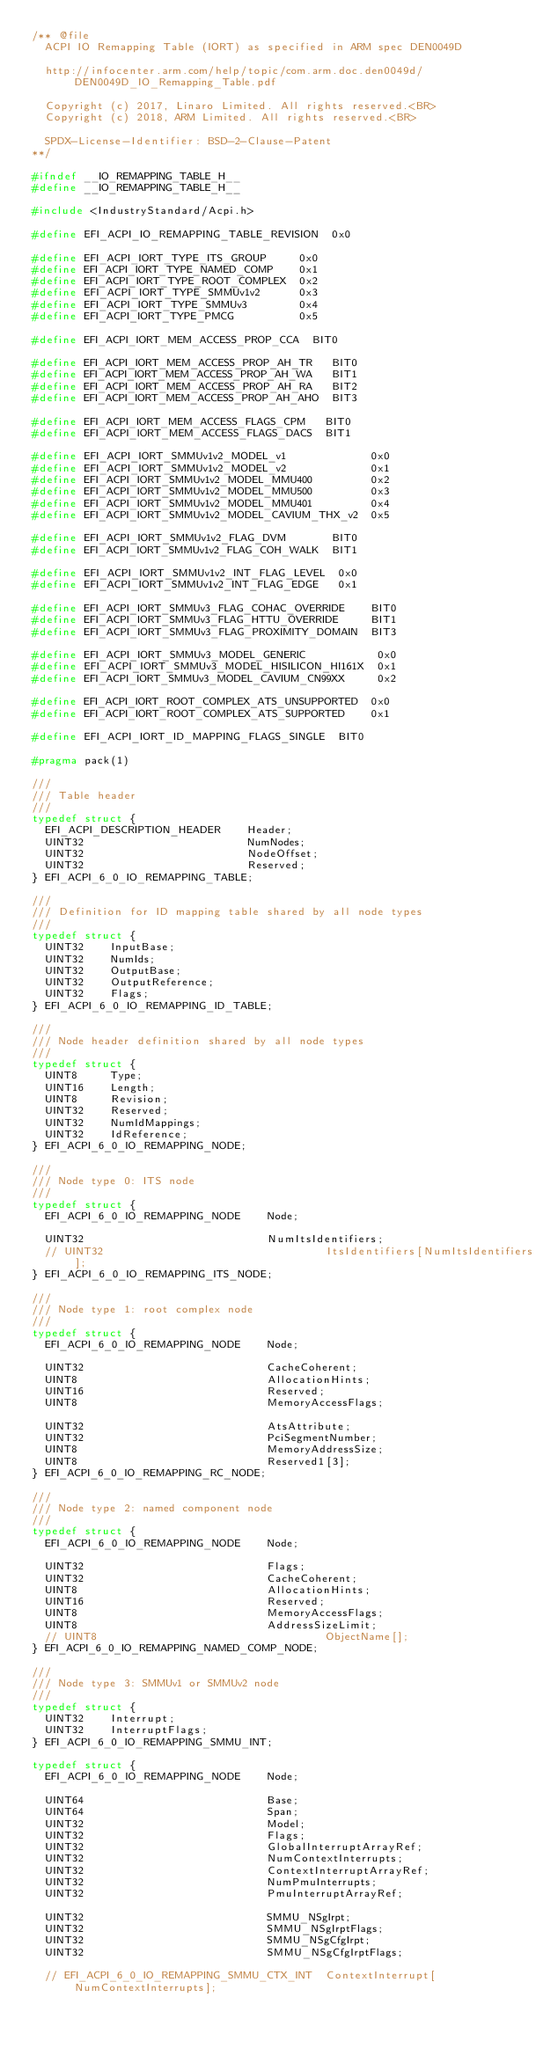<code> <loc_0><loc_0><loc_500><loc_500><_C_>/** @file
  ACPI IO Remapping Table (IORT) as specified in ARM spec DEN0049D

  http://infocenter.arm.com/help/topic/com.arm.doc.den0049d/DEN0049D_IO_Remapping_Table.pdf

  Copyright (c) 2017, Linaro Limited. All rights reserved.<BR>
  Copyright (c) 2018, ARM Limited. All rights reserved.<BR>

  SPDX-License-Identifier: BSD-2-Clause-Patent
**/

#ifndef __IO_REMAPPING_TABLE_H__
#define __IO_REMAPPING_TABLE_H__

#include <IndustryStandard/Acpi.h>

#define EFI_ACPI_IO_REMAPPING_TABLE_REVISION  0x0

#define EFI_ACPI_IORT_TYPE_ITS_GROUP     0x0
#define EFI_ACPI_IORT_TYPE_NAMED_COMP    0x1
#define EFI_ACPI_IORT_TYPE_ROOT_COMPLEX  0x2
#define EFI_ACPI_IORT_TYPE_SMMUv1v2      0x3
#define EFI_ACPI_IORT_TYPE_SMMUv3        0x4
#define EFI_ACPI_IORT_TYPE_PMCG          0x5

#define EFI_ACPI_IORT_MEM_ACCESS_PROP_CCA  BIT0

#define EFI_ACPI_IORT_MEM_ACCESS_PROP_AH_TR   BIT0
#define EFI_ACPI_IORT_MEM_ACCESS_PROP_AH_WA   BIT1
#define EFI_ACPI_IORT_MEM_ACCESS_PROP_AH_RA   BIT2
#define EFI_ACPI_IORT_MEM_ACCESS_PROP_AH_AHO  BIT3

#define EFI_ACPI_IORT_MEM_ACCESS_FLAGS_CPM   BIT0
#define EFI_ACPI_IORT_MEM_ACCESS_FLAGS_DACS  BIT1

#define EFI_ACPI_IORT_SMMUv1v2_MODEL_v1             0x0
#define EFI_ACPI_IORT_SMMUv1v2_MODEL_v2             0x1
#define EFI_ACPI_IORT_SMMUv1v2_MODEL_MMU400         0x2
#define EFI_ACPI_IORT_SMMUv1v2_MODEL_MMU500         0x3
#define EFI_ACPI_IORT_SMMUv1v2_MODEL_MMU401         0x4
#define EFI_ACPI_IORT_SMMUv1v2_MODEL_CAVIUM_THX_v2  0x5

#define EFI_ACPI_IORT_SMMUv1v2_FLAG_DVM       BIT0
#define EFI_ACPI_IORT_SMMUv1v2_FLAG_COH_WALK  BIT1

#define EFI_ACPI_IORT_SMMUv1v2_INT_FLAG_LEVEL  0x0
#define EFI_ACPI_IORT_SMMUv1v2_INT_FLAG_EDGE   0x1

#define EFI_ACPI_IORT_SMMUv3_FLAG_COHAC_OVERRIDE    BIT0
#define EFI_ACPI_IORT_SMMUv3_FLAG_HTTU_OVERRIDE     BIT1
#define EFI_ACPI_IORT_SMMUv3_FLAG_PROXIMITY_DOMAIN  BIT3

#define EFI_ACPI_IORT_SMMUv3_MODEL_GENERIC           0x0
#define EFI_ACPI_IORT_SMMUv3_MODEL_HISILICON_HI161X  0x1
#define EFI_ACPI_IORT_SMMUv3_MODEL_CAVIUM_CN99XX     0x2

#define EFI_ACPI_IORT_ROOT_COMPLEX_ATS_UNSUPPORTED  0x0
#define EFI_ACPI_IORT_ROOT_COMPLEX_ATS_SUPPORTED    0x1

#define EFI_ACPI_IORT_ID_MAPPING_FLAGS_SINGLE  BIT0

#pragma pack(1)

///
/// Table header
///
typedef struct {
  EFI_ACPI_DESCRIPTION_HEADER    Header;
  UINT32                         NumNodes;
  UINT32                         NodeOffset;
  UINT32                         Reserved;
} EFI_ACPI_6_0_IO_REMAPPING_TABLE;

///
/// Definition for ID mapping table shared by all node types
///
typedef struct {
  UINT32    InputBase;
  UINT32    NumIds;
  UINT32    OutputBase;
  UINT32    OutputReference;
  UINT32    Flags;
} EFI_ACPI_6_0_IO_REMAPPING_ID_TABLE;

///
/// Node header definition shared by all node types
///
typedef struct {
  UINT8     Type;
  UINT16    Length;
  UINT8     Revision;
  UINT32    Reserved;
  UINT32    NumIdMappings;
  UINT32    IdReference;
} EFI_ACPI_6_0_IO_REMAPPING_NODE;

///
/// Node type 0: ITS node
///
typedef struct {
  EFI_ACPI_6_0_IO_REMAPPING_NODE    Node;

  UINT32                            NumItsIdentifiers;
  // UINT32                                  ItsIdentifiers[NumItsIdentifiers];
} EFI_ACPI_6_0_IO_REMAPPING_ITS_NODE;

///
/// Node type 1: root complex node
///
typedef struct {
  EFI_ACPI_6_0_IO_REMAPPING_NODE    Node;

  UINT32                            CacheCoherent;
  UINT8                             AllocationHints;
  UINT16                            Reserved;
  UINT8                             MemoryAccessFlags;

  UINT32                            AtsAttribute;
  UINT32                            PciSegmentNumber;
  UINT8                             MemoryAddressSize;
  UINT8                             Reserved1[3];
} EFI_ACPI_6_0_IO_REMAPPING_RC_NODE;

///
/// Node type 2: named component node
///
typedef struct {
  EFI_ACPI_6_0_IO_REMAPPING_NODE    Node;

  UINT32                            Flags;
  UINT32                            CacheCoherent;
  UINT8                             AllocationHints;
  UINT16                            Reserved;
  UINT8                             MemoryAccessFlags;
  UINT8                             AddressSizeLimit;
  // UINT8                                   ObjectName[];
} EFI_ACPI_6_0_IO_REMAPPING_NAMED_COMP_NODE;

///
/// Node type 3: SMMUv1 or SMMUv2 node
///
typedef struct {
  UINT32    Interrupt;
  UINT32    InterruptFlags;
} EFI_ACPI_6_0_IO_REMAPPING_SMMU_INT;

typedef struct {
  EFI_ACPI_6_0_IO_REMAPPING_NODE    Node;

  UINT64                            Base;
  UINT64                            Span;
  UINT32                            Model;
  UINT32                            Flags;
  UINT32                            GlobalInterruptArrayRef;
  UINT32                            NumContextInterrupts;
  UINT32                            ContextInterruptArrayRef;
  UINT32                            NumPmuInterrupts;
  UINT32                            PmuInterruptArrayRef;

  UINT32                            SMMU_NSgIrpt;
  UINT32                            SMMU_NSgIrptFlags;
  UINT32                            SMMU_NSgCfgIrpt;
  UINT32                            SMMU_NSgCfgIrptFlags;

  // EFI_ACPI_6_0_IO_REMAPPING_SMMU_CTX_INT  ContextInterrupt[NumContextInterrupts];</code> 